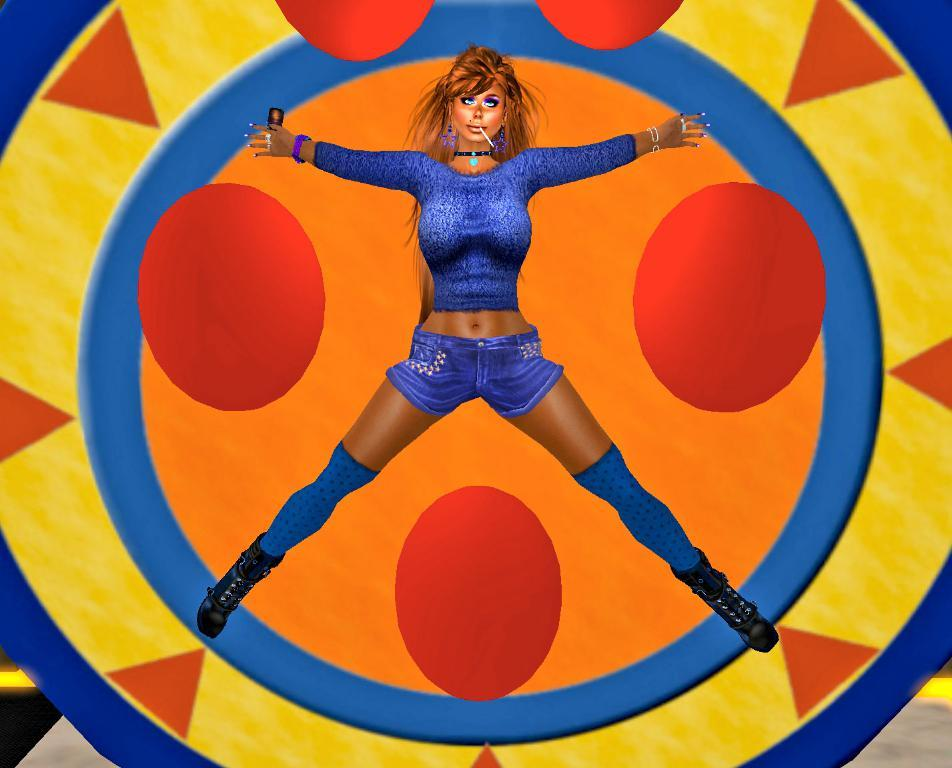What type of image is being described? The image is animated. Can you describe the character in the image? There is there a woman in the image? What is the woman wearing? The woman is wearing a violet color dress. Where is the woman located in the image? The woman is on a circular device. Are there any fangs visible on the woman in the image? No, there are no fangs visible on the woman in the image. Can you see any tomatoes growing in the background of the image? There is no mention of tomatoes or a background in the provided facts, so it cannot be determined if they are present in the image. 